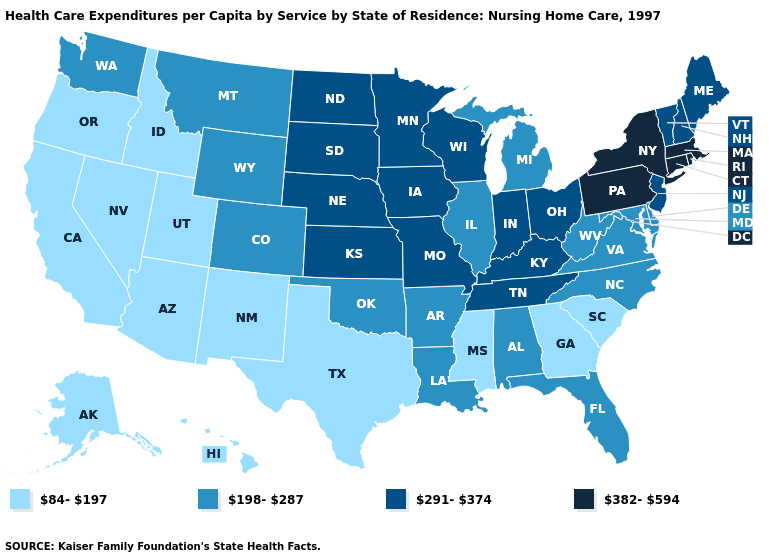Name the states that have a value in the range 198-287?
Give a very brief answer. Alabama, Arkansas, Colorado, Delaware, Florida, Illinois, Louisiana, Maryland, Michigan, Montana, North Carolina, Oklahoma, Virginia, Washington, West Virginia, Wyoming. Among the states that border Alabama , does Tennessee have the highest value?
Short answer required. Yes. What is the value of Wyoming?
Write a very short answer. 198-287. Which states hav the highest value in the Northeast?
Quick response, please. Connecticut, Massachusetts, New York, Pennsylvania, Rhode Island. What is the highest value in the South ?
Be succinct. 291-374. Name the states that have a value in the range 382-594?
Concise answer only. Connecticut, Massachusetts, New York, Pennsylvania, Rhode Island. What is the value of Alabama?
Short answer required. 198-287. Which states have the highest value in the USA?
Give a very brief answer. Connecticut, Massachusetts, New York, Pennsylvania, Rhode Island. What is the value of Washington?
Short answer required. 198-287. What is the highest value in the USA?
Write a very short answer. 382-594. Name the states that have a value in the range 291-374?
Write a very short answer. Indiana, Iowa, Kansas, Kentucky, Maine, Minnesota, Missouri, Nebraska, New Hampshire, New Jersey, North Dakota, Ohio, South Dakota, Tennessee, Vermont, Wisconsin. How many symbols are there in the legend?
Keep it brief. 4. Does California have a lower value than Kansas?
Answer briefly. Yes. Name the states that have a value in the range 382-594?
Answer briefly. Connecticut, Massachusetts, New York, Pennsylvania, Rhode Island. Does Missouri have the lowest value in the USA?
Keep it brief. No. 